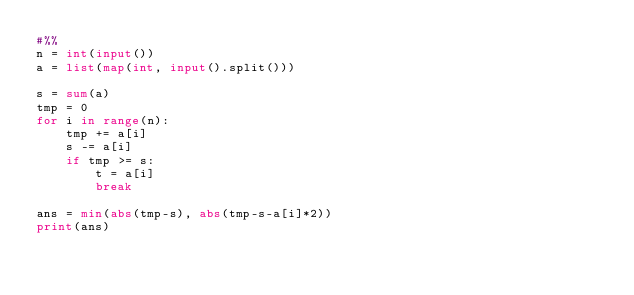Convert code to text. <code><loc_0><loc_0><loc_500><loc_500><_Python_>#%%
n = int(input())
a = list(map(int, input().split()))

s = sum(a)
tmp = 0
for i in range(n):
    tmp += a[i]
    s -= a[i]
    if tmp >= s:
        t = a[i]
        break

ans = min(abs(tmp-s), abs(tmp-s-a[i]*2))
print(ans)</code> 